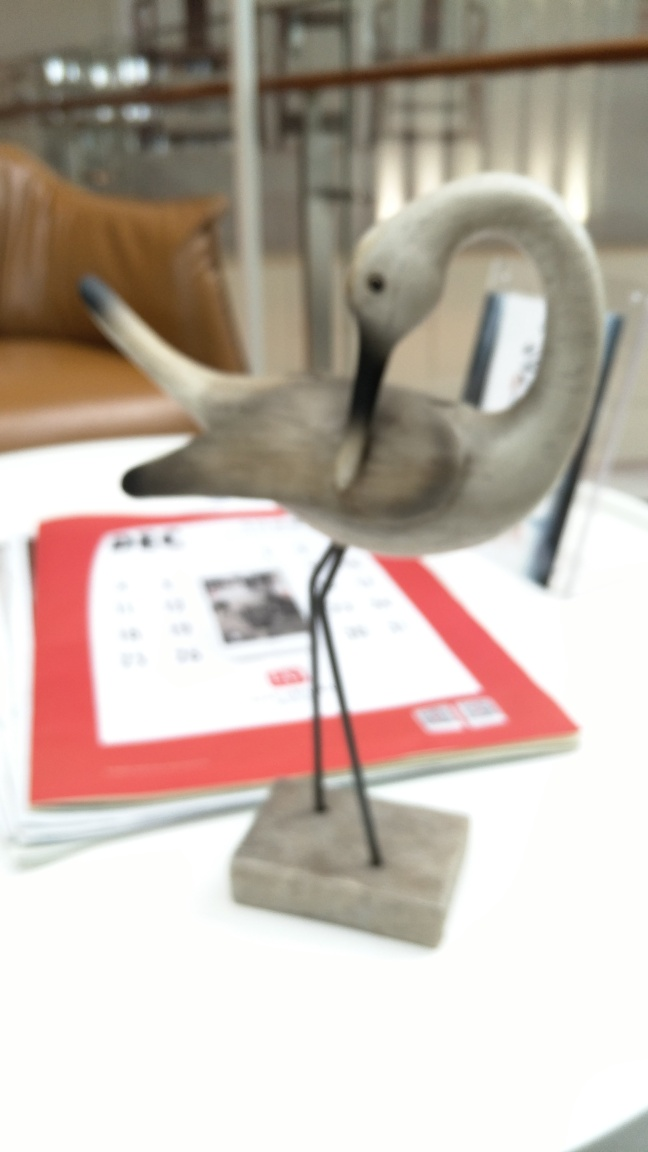What might be the significance of the object the crane is on? The crane rests on what seems to be a calendar or a publication, which could imply that it's a part of a desk setup, potentially used for organizational purposes or to mark a special date. 